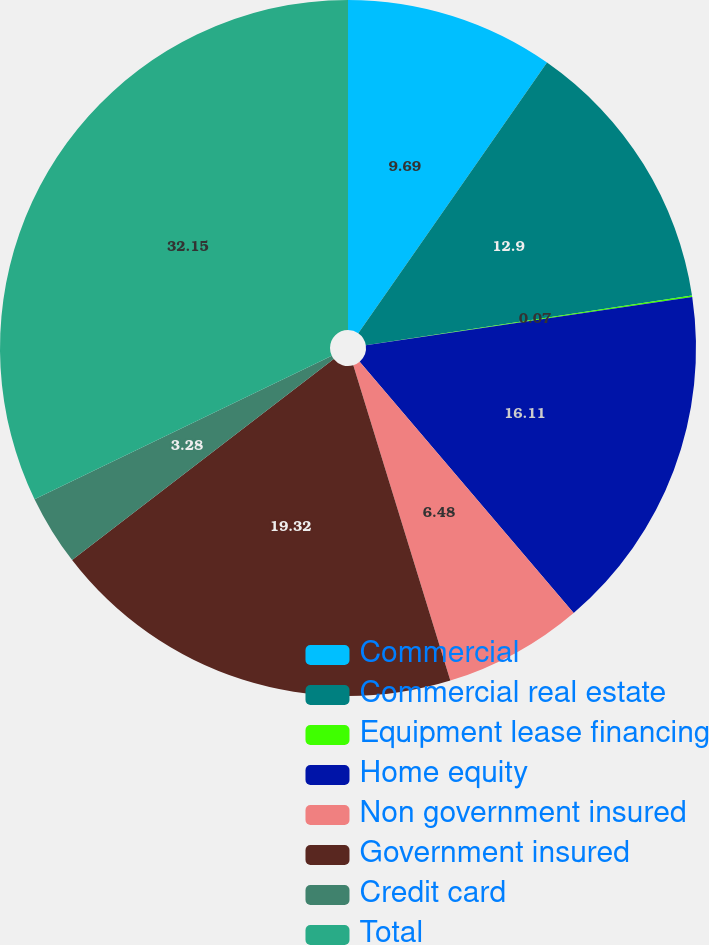Convert chart to OTSL. <chart><loc_0><loc_0><loc_500><loc_500><pie_chart><fcel>Commercial<fcel>Commercial real estate<fcel>Equipment lease financing<fcel>Home equity<fcel>Non government insured<fcel>Government insured<fcel>Credit card<fcel>Total<nl><fcel>9.69%<fcel>12.9%<fcel>0.07%<fcel>16.11%<fcel>6.48%<fcel>19.32%<fcel>3.28%<fcel>32.15%<nl></chart> 